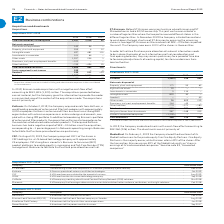According to Lm Ericsson Telephone's financial document, What is the total consideration for 2017? According to the financial document, 62 (in millions). The relevant text states: "Total consideration, including cash 1,957 1,314 62..." Also, How many employees are in Kathrein? According to the financial document, approximately 4,000. The relevant text states: "provider of antenna and filter technologies with approximately 4,000 employees. Kathrein’s antenna and filters business has a strong R&D organization with extensive exp..." Also, When is CSF being acquired? According to the financial document, August 20, 2019. The relevant text states: "CSF: On August 20, 2019, the Company acquired 100% of the shares in CSF Holdings Inc. a US-based technology company with ap..." Also, can you calculate: What is the change in cash and cash equivalents between 2019 and 2018? Based on the calculation: 142-94, the result is 48 (in millions). This is based on the information: "Net assets acquired Cash and cash equivalents 142 94 – Property, plant and equipment 353 4 12 Intangible assets 497 481 101 Investments in associates 10 Net assets acquired Cash and cash equivalents 1..." The key data points involved are: 142, 94. Also, can you calculate: What is the total acquisition-related costs from 2017 to 2019? Based on the calculation: 85+24+49, the result is 158 (in millions). This is based on the information: "1,957 1,314 62 Acquisition-related costs 1) 85 24 49 Total 1,957 1,314 62 Acquisition-related costs 1) 85 24 49 al 1,957 1,314 62 Acquisition-related costs 1) 85 24 49..." The key data points involved are: 24, 49, 85. Also, can you calculate: What is the change in total consideration between 2019 and 2018? Based on the calculation: 1,957-1,314, the result is 643 (in millions). This is based on the information: "Total consideration, including cash 1,957 1,314 62 Total consideration, including cash 1,957 1,314 62..." The key data points involved are: 1,314, 1,957. 